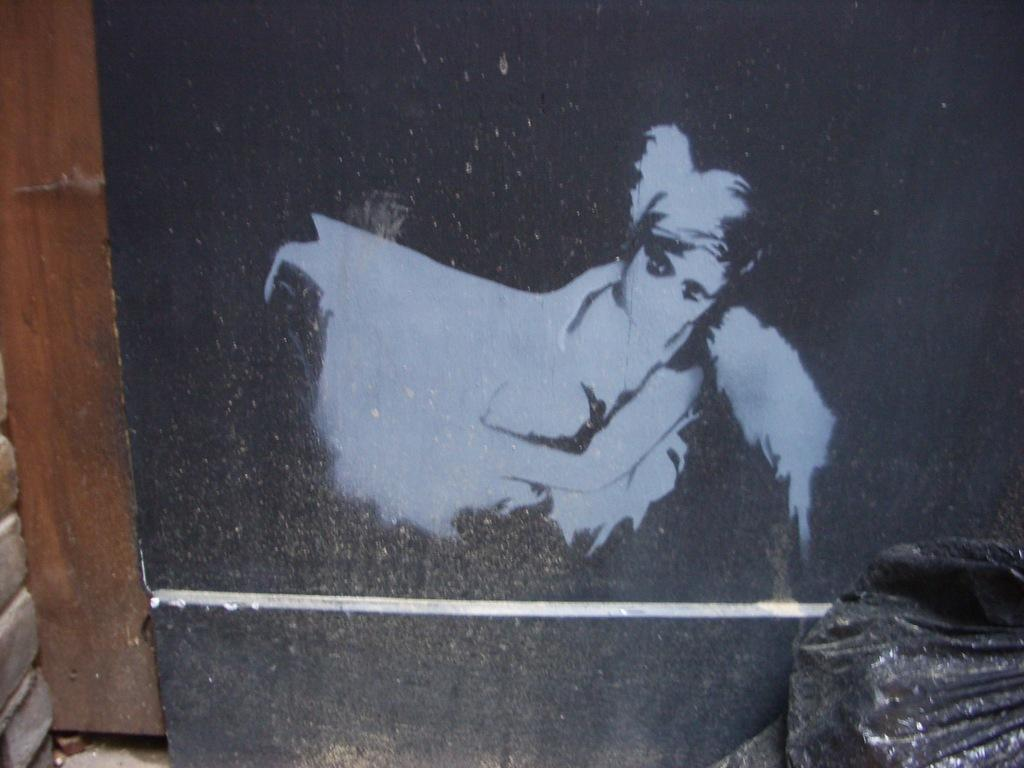What is depicted on the object in the image? There is a painting on an object in the image. Can you describe the object at the right side of the image? There is an object at the right side of the image, but no specific details are provided about its appearance or characteristics. What type of song can be heard playing in the background of the image? There is no information about any sounds or music in the image, so it is not possible to determine if a song is playing. 